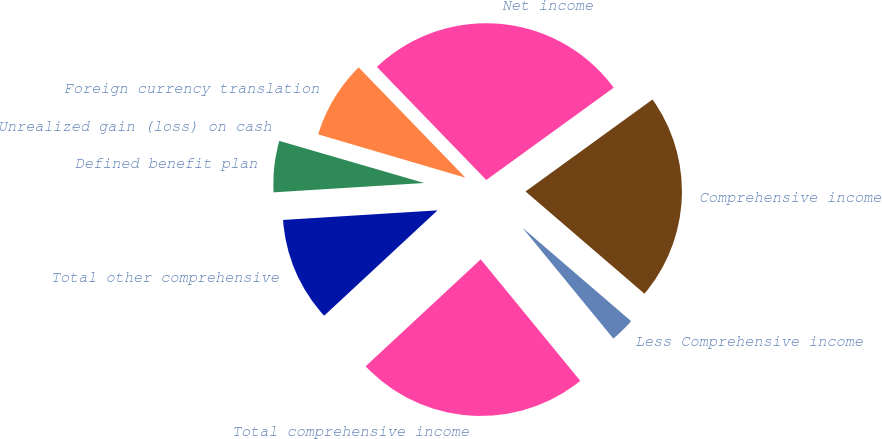<chart> <loc_0><loc_0><loc_500><loc_500><pie_chart><fcel>Net income<fcel>Foreign currency translation<fcel>Unrealized gain (loss) on cash<fcel>Defined benefit plan<fcel>Total other comprehensive<fcel>Total comprehensive income<fcel>Less Comprehensive income<fcel>Comprehensive income<nl><fcel>27.26%<fcel>8.21%<fcel>0.05%<fcel>5.49%<fcel>10.93%<fcel>24.01%<fcel>2.77%<fcel>21.28%<nl></chart> 